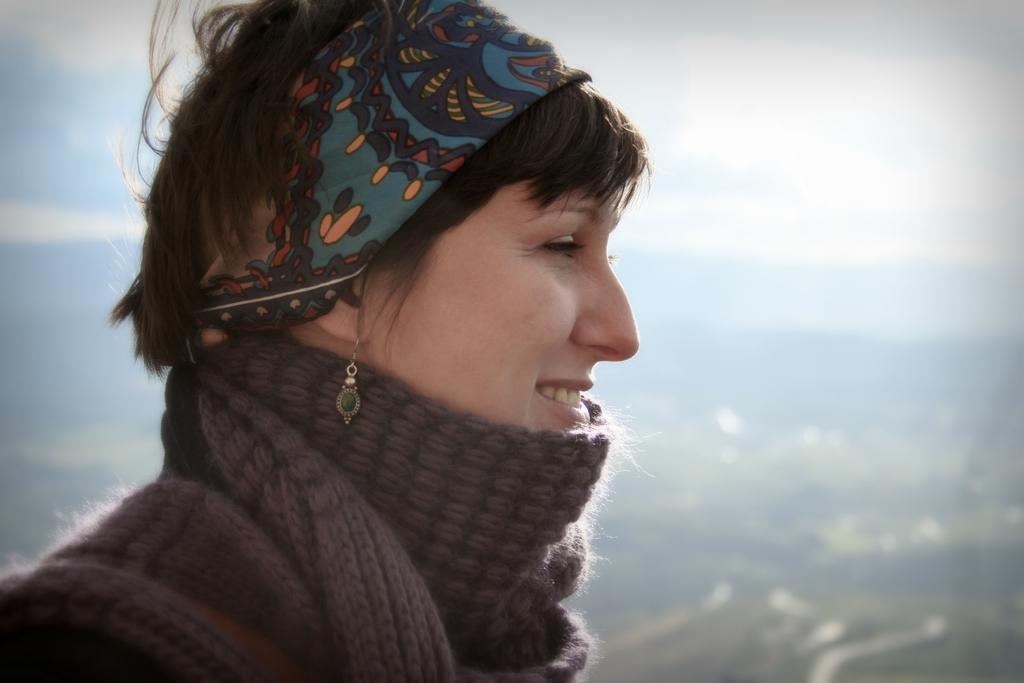In one or two sentences, can you explain what this image depicts? In the foreground of this image, there is a woman wearing scarf around her neck and a head band on her head. In the background, there is greenery. On the top, there is the sky and the cloud. 